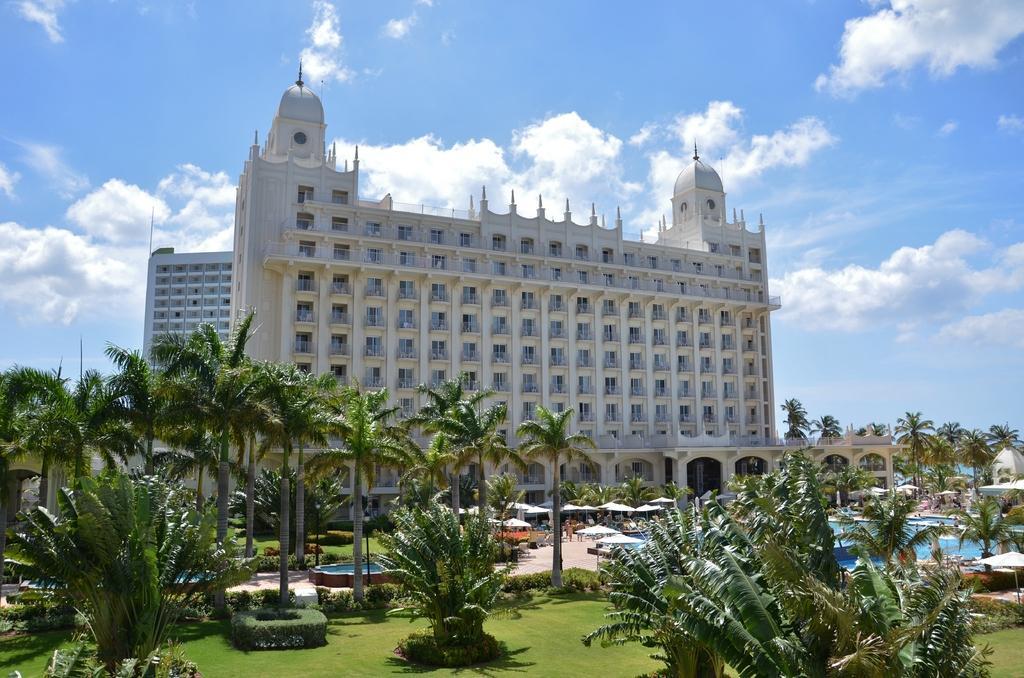What type of structures can be seen in the image? There are buildings in the image. What type of vegetation is present in the image? There are trees, shrubs, and bushes in the image. What type of shade provider is visible in the image? There are parasols in the image. What are the people in the image doing? There are persons standing on the floor in the image. What type of water feature is present in the image? There is a swimming pool in the image. What type of surface is visible in the image? There is ground visible in the image. What type of support structures are present in the image? There are poles in the image. What is visible in the sky in the image? The sky is visible in the image, and there are clouds in the sky. What type of sail can be seen on the persons in the image? There is no sail present in the image; the people are standing on the ground. What type of action is the stocking performing in the image? There is no stocking present in the image, and therefore no action can be attributed to it. 